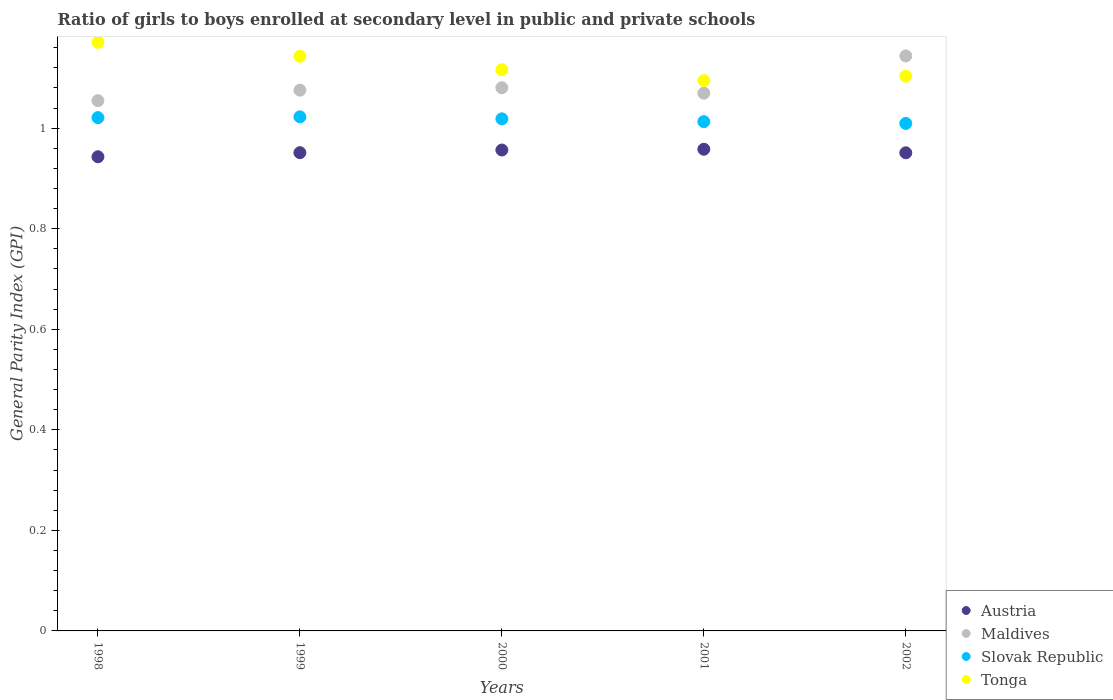How many different coloured dotlines are there?
Keep it short and to the point. 4. What is the general parity index in Slovak Republic in 1999?
Ensure brevity in your answer.  1.02. Across all years, what is the maximum general parity index in Austria?
Your answer should be compact. 0.96. Across all years, what is the minimum general parity index in Maldives?
Your response must be concise. 1.05. In which year was the general parity index in Austria maximum?
Provide a succinct answer. 2001. What is the total general parity index in Austria in the graph?
Ensure brevity in your answer.  4.76. What is the difference between the general parity index in Maldives in 1998 and that in 2000?
Provide a short and direct response. -0.03. What is the difference between the general parity index in Austria in 2002 and the general parity index in Maldives in 2000?
Keep it short and to the point. -0.13. What is the average general parity index in Slovak Republic per year?
Your answer should be very brief. 1.02. In the year 2001, what is the difference between the general parity index in Maldives and general parity index in Slovak Republic?
Provide a short and direct response. 0.06. In how many years, is the general parity index in Slovak Republic greater than 0.16?
Provide a short and direct response. 5. What is the ratio of the general parity index in Austria in 2001 to that in 2002?
Offer a very short reply. 1.01. Is the general parity index in Tonga in 1998 less than that in 2002?
Your answer should be compact. No. What is the difference between the highest and the second highest general parity index in Slovak Republic?
Your answer should be compact. 0. What is the difference between the highest and the lowest general parity index in Austria?
Make the answer very short. 0.01. Is it the case that in every year, the sum of the general parity index in Maldives and general parity index in Austria  is greater than the general parity index in Tonga?
Keep it short and to the point. Yes. Does the general parity index in Austria monotonically increase over the years?
Ensure brevity in your answer.  No. Is the general parity index in Tonga strictly greater than the general parity index in Austria over the years?
Ensure brevity in your answer.  Yes. How many years are there in the graph?
Make the answer very short. 5. Are the values on the major ticks of Y-axis written in scientific E-notation?
Your answer should be compact. No. Does the graph contain any zero values?
Offer a very short reply. No. Where does the legend appear in the graph?
Provide a succinct answer. Bottom right. What is the title of the graph?
Offer a very short reply. Ratio of girls to boys enrolled at secondary level in public and private schools. Does "Gabon" appear as one of the legend labels in the graph?
Your response must be concise. No. What is the label or title of the Y-axis?
Provide a short and direct response. General Parity Index (GPI). What is the General Parity Index (GPI) in Austria in 1998?
Your answer should be compact. 0.94. What is the General Parity Index (GPI) of Maldives in 1998?
Ensure brevity in your answer.  1.05. What is the General Parity Index (GPI) in Slovak Republic in 1998?
Your answer should be compact. 1.02. What is the General Parity Index (GPI) in Tonga in 1998?
Your answer should be very brief. 1.17. What is the General Parity Index (GPI) of Austria in 1999?
Give a very brief answer. 0.95. What is the General Parity Index (GPI) in Maldives in 1999?
Offer a very short reply. 1.08. What is the General Parity Index (GPI) in Slovak Republic in 1999?
Your answer should be very brief. 1.02. What is the General Parity Index (GPI) of Tonga in 1999?
Offer a very short reply. 1.14. What is the General Parity Index (GPI) of Austria in 2000?
Keep it short and to the point. 0.96. What is the General Parity Index (GPI) of Maldives in 2000?
Give a very brief answer. 1.08. What is the General Parity Index (GPI) of Slovak Republic in 2000?
Ensure brevity in your answer.  1.02. What is the General Parity Index (GPI) in Tonga in 2000?
Your answer should be very brief. 1.12. What is the General Parity Index (GPI) of Austria in 2001?
Offer a terse response. 0.96. What is the General Parity Index (GPI) of Maldives in 2001?
Provide a succinct answer. 1.07. What is the General Parity Index (GPI) of Slovak Republic in 2001?
Provide a succinct answer. 1.01. What is the General Parity Index (GPI) in Tonga in 2001?
Offer a terse response. 1.09. What is the General Parity Index (GPI) in Austria in 2002?
Offer a terse response. 0.95. What is the General Parity Index (GPI) of Maldives in 2002?
Give a very brief answer. 1.14. What is the General Parity Index (GPI) of Slovak Republic in 2002?
Provide a short and direct response. 1.01. What is the General Parity Index (GPI) in Tonga in 2002?
Provide a short and direct response. 1.1. Across all years, what is the maximum General Parity Index (GPI) in Austria?
Make the answer very short. 0.96. Across all years, what is the maximum General Parity Index (GPI) of Maldives?
Make the answer very short. 1.14. Across all years, what is the maximum General Parity Index (GPI) in Slovak Republic?
Provide a succinct answer. 1.02. Across all years, what is the maximum General Parity Index (GPI) of Tonga?
Your response must be concise. 1.17. Across all years, what is the minimum General Parity Index (GPI) in Austria?
Make the answer very short. 0.94. Across all years, what is the minimum General Parity Index (GPI) of Maldives?
Your answer should be very brief. 1.05. Across all years, what is the minimum General Parity Index (GPI) in Slovak Republic?
Give a very brief answer. 1.01. Across all years, what is the minimum General Parity Index (GPI) of Tonga?
Ensure brevity in your answer.  1.09. What is the total General Parity Index (GPI) of Austria in the graph?
Ensure brevity in your answer.  4.76. What is the total General Parity Index (GPI) of Maldives in the graph?
Provide a short and direct response. 5.42. What is the total General Parity Index (GPI) in Slovak Republic in the graph?
Offer a terse response. 5.08. What is the total General Parity Index (GPI) of Tonga in the graph?
Ensure brevity in your answer.  5.63. What is the difference between the General Parity Index (GPI) of Austria in 1998 and that in 1999?
Offer a very short reply. -0.01. What is the difference between the General Parity Index (GPI) in Maldives in 1998 and that in 1999?
Offer a very short reply. -0.02. What is the difference between the General Parity Index (GPI) of Slovak Republic in 1998 and that in 1999?
Your answer should be very brief. -0. What is the difference between the General Parity Index (GPI) of Tonga in 1998 and that in 1999?
Provide a short and direct response. 0.03. What is the difference between the General Parity Index (GPI) of Austria in 1998 and that in 2000?
Ensure brevity in your answer.  -0.01. What is the difference between the General Parity Index (GPI) of Maldives in 1998 and that in 2000?
Your answer should be compact. -0.03. What is the difference between the General Parity Index (GPI) of Slovak Republic in 1998 and that in 2000?
Your answer should be very brief. 0. What is the difference between the General Parity Index (GPI) of Tonga in 1998 and that in 2000?
Provide a succinct answer. 0.05. What is the difference between the General Parity Index (GPI) of Austria in 1998 and that in 2001?
Your answer should be very brief. -0.01. What is the difference between the General Parity Index (GPI) in Maldives in 1998 and that in 2001?
Provide a short and direct response. -0.01. What is the difference between the General Parity Index (GPI) of Slovak Republic in 1998 and that in 2001?
Your response must be concise. 0.01. What is the difference between the General Parity Index (GPI) of Tonga in 1998 and that in 2001?
Offer a very short reply. 0.08. What is the difference between the General Parity Index (GPI) in Austria in 1998 and that in 2002?
Ensure brevity in your answer.  -0.01. What is the difference between the General Parity Index (GPI) in Maldives in 1998 and that in 2002?
Keep it short and to the point. -0.09. What is the difference between the General Parity Index (GPI) in Slovak Republic in 1998 and that in 2002?
Your answer should be compact. 0.01. What is the difference between the General Parity Index (GPI) in Tonga in 1998 and that in 2002?
Your response must be concise. 0.07. What is the difference between the General Parity Index (GPI) of Austria in 1999 and that in 2000?
Keep it short and to the point. -0.01. What is the difference between the General Parity Index (GPI) of Maldives in 1999 and that in 2000?
Your answer should be very brief. -0. What is the difference between the General Parity Index (GPI) of Slovak Republic in 1999 and that in 2000?
Provide a succinct answer. 0. What is the difference between the General Parity Index (GPI) in Tonga in 1999 and that in 2000?
Provide a succinct answer. 0.03. What is the difference between the General Parity Index (GPI) in Austria in 1999 and that in 2001?
Give a very brief answer. -0.01. What is the difference between the General Parity Index (GPI) in Maldives in 1999 and that in 2001?
Offer a very short reply. 0.01. What is the difference between the General Parity Index (GPI) in Slovak Republic in 1999 and that in 2001?
Provide a short and direct response. 0.01. What is the difference between the General Parity Index (GPI) in Tonga in 1999 and that in 2001?
Keep it short and to the point. 0.05. What is the difference between the General Parity Index (GPI) of Maldives in 1999 and that in 2002?
Ensure brevity in your answer.  -0.07. What is the difference between the General Parity Index (GPI) in Slovak Republic in 1999 and that in 2002?
Provide a short and direct response. 0.01. What is the difference between the General Parity Index (GPI) of Tonga in 1999 and that in 2002?
Your response must be concise. 0.04. What is the difference between the General Parity Index (GPI) of Austria in 2000 and that in 2001?
Your answer should be very brief. -0. What is the difference between the General Parity Index (GPI) in Maldives in 2000 and that in 2001?
Offer a very short reply. 0.01. What is the difference between the General Parity Index (GPI) of Slovak Republic in 2000 and that in 2001?
Your answer should be compact. 0.01. What is the difference between the General Parity Index (GPI) of Tonga in 2000 and that in 2001?
Your answer should be compact. 0.02. What is the difference between the General Parity Index (GPI) in Austria in 2000 and that in 2002?
Offer a terse response. 0.01. What is the difference between the General Parity Index (GPI) of Maldives in 2000 and that in 2002?
Offer a terse response. -0.06. What is the difference between the General Parity Index (GPI) of Slovak Republic in 2000 and that in 2002?
Provide a short and direct response. 0.01. What is the difference between the General Parity Index (GPI) of Tonga in 2000 and that in 2002?
Provide a succinct answer. 0.01. What is the difference between the General Parity Index (GPI) of Austria in 2001 and that in 2002?
Your answer should be compact. 0.01. What is the difference between the General Parity Index (GPI) of Maldives in 2001 and that in 2002?
Give a very brief answer. -0.07. What is the difference between the General Parity Index (GPI) in Slovak Republic in 2001 and that in 2002?
Ensure brevity in your answer.  0. What is the difference between the General Parity Index (GPI) of Tonga in 2001 and that in 2002?
Offer a very short reply. -0.01. What is the difference between the General Parity Index (GPI) in Austria in 1998 and the General Parity Index (GPI) in Maldives in 1999?
Your response must be concise. -0.13. What is the difference between the General Parity Index (GPI) in Austria in 1998 and the General Parity Index (GPI) in Slovak Republic in 1999?
Offer a terse response. -0.08. What is the difference between the General Parity Index (GPI) in Maldives in 1998 and the General Parity Index (GPI) in Slovak Republic in 1999?
Ensure brevity in your answer.  0.03. What is the difference between the General Parity Index (GPI) of Maldives in 1998 and the General Parity Index (GPI) of Tonga in 1999?
Your response must be concise. -0.09. What is the difference between the General Parity Index (GPI) in Slovak Republic in 1998 and the General Parity Index (GPI) in Tonga in 1999?
Provide a succinct answer. -0.12. What is the difference between the General Parity Index (GPI) in Austria in 1998 and the General Parity Index (GPI) in Maldives in 2000?
Give a very brief answer. -0.14. What is the difference between the General Parity Index (GPI) in Austria in 1998 and the General Parity Index (GPI) in Slovak Republic in 2000?
Your response must be concise. -0.08. What is the difference between the General Parity Index (GPI) in Austria in 1998 and the General Parity Index (GPI) in Tonga in 2000?
Provide a short and direct response. -0.17. What is the difference between the General Parity Index (GPI) of Maldives in 1998 and the General Parity Index (GPI) of Slovak Republic in 2000?
Give a very brief answer. 0.04. What is the difference between the General Parity Index (GPI) of Maldives in 1998 and the General Parity Index (GPI) of Tonga in 2000?
Keep it short and to the point. -0.06. What is the difference between the General Parity Index (GPI) of Slovak Republic in 1998 and the General Parity Index (GPI) of Tonga in 2000?
Your answer should be very brief. -0.1. What is the difference between the General Parity Index (GPI) of Austria in 1998 and the General Parity Index (GPI) of Maldives in 2001?
Offer a terse response. -0.13. What is the difference between the General Parity Index (GPI) of Austria in 1998 and the General Parity Index (GPI) of Slovak Republic in 2001?
Your answer should be very brief. -0.07. What is the difference between the General Parity Index (GPI) of Austria in 1998 and the General Parity Index (GPI) of Tonga in 2001?
Your answer should be compact. -0.15. What is the difference between the General Parity Index (GPI) in Maldives in 1998 and the General Parity Index (GPI) in Slovak Republic in 2001?
Offer a terse response. 0.04. What is the difference between the General Parity Index (GPI) in Maldives in 1998 and the General Parity Index (GPI) in Tonga in 2001?
Offer a terse response. -0.04. What is the difference between the General Parity Index (GPI) in Slovak Republic in 1998 and the General Parity Index (GPI) in Tonga in 2001?
Keep it short and to the point. -0.07. What is the difference between the General Parity Index (GPI) of Austria in 1998 and the General Parity Index (GPI) of Maldives in 2002?
Your response must be concise. -0.2. What is the difference between the General Parity Index (GPI) in Austria in 1998 and the General Parity Index (GPI) in Slovak Republic in 2002?
Your response must be concise. -0.07. What is the difference between the General Parity Index (GPI) of Austria in 1998 and the General Parity Index (GPI) of Tonga in 2002?
Make the answer very short. -0.16. What is the difference between the General Parity Index (GPI) of Maldives in 1998 and the General Parity Index (GPI) of Slovak Republic in 2002?
Keep it short and to the point. 0.05. What is the difference between the General Parity Index (GPI) in Maldives in 1998 and the General Parity Index (GPI) in Tonga in 2002?
Ensure brevity in your answer.  -0.05. What is the difference between the General Parity Index (GPI) in Slovak Republic in 1998 and the General Parity Index (GPI) in Tonga in 2002?
Your answer should be compact. -0.08. What is the difference between the General Parity Index (GPI) in Austria in 1999 and the General Parity Index (GPI) in Maldives in 2000?
Your answer should be compact. -0.13. What is the difference between the General Parity Index (GPI) of Austria in 1999 and the General Parity Index (GPI) of Slovak Republic in 2000?
Make the answer very short. -0.07. What is the difference between the General Parity Index (GPI) in Austria in 1999 and the General Parity Index (GPI) in Tonga in 2000?
Your answer should be very brief. -0.16. What is the difference between the General Parity Index (GPI) in Maldives in 1999 and the General Parity Index (GPI) in Slovak Republic in 2000?
Your response must be concise. 0.06. What is the difference between the General Parity Index (GPI) in Maldives in 1999 and the General Parity Index (GPI) in Tonga in 2000?
Provide a short and direct response. -0.04. What is the difference between the General Parity Index (GPI) in Slovak Republic in 1999 and the General Parity Index (GPI) in Tonga in 2000?
Your answer should be compact. -0.09. What is the difference between the General Parity Index (GPI) in Austria in 1999 and the General Parity Index (GPI) in Maldives in 2001?
Your response must be concise. -0.12. What is the difference between the General Parity Index (GPI) of Austria in 1999 and the General Parity Index (GPI) of Slovak Republic in 2001?
Give a very brief answer. -0.06. What is the difference between the General Parity Index (GPI) in Austria in 1999 and the General Parity Index (GPI) in Tonga in 2001?
Offer a terse response. -0.14. What is the difference between the General Parity Index (GPI) of Maldives in 1999 and the General Parity Index (GPI) of Slovak Republic in 2001?
Your answer should be compact. 0.06. What is the difference between the General Parity Index (GPI) of Maldives in 1999 and the General Parity Index (GPI) of Tonga in 2001?
Provide a short and direct response. -0.02. What is the difference between the General Parity Index (GPI) of Slovak Republic in 1999 and the General Parity Index (GPI) of Tonga in 2001?
Your answer should be very brief. -0.07. What is the difference between the General Parity Index (GPI) of Austria in 1999 and the General Parity Index (GPI) of Maldives in 2002?
Provide a short and direct response. -0.19. What is the difference between the General Parity Index (GPI) of Austria in 1999 and the General Parity Index (GPI) of Slovak Republic in 2002?
Offer a terse response. -0.06. What is the difference between the General Parity Index (GPI) in Austria in 1999 and the General Parity Index (GPI) in Tonga in 2002?
Provide a short and direct response. -0.15. What is the difference between the General Parity Index (GPI) of Maldives in 1999 and the General Parity Index (GPI) of Slovak Republic in 2002?
Keep it short and to the point. 0.07. What is the difference between the General Parity Index (GPI) in Maldives in 1999 and the General Parity Index (GPI) in Tonga in 2002?
Make the answer very short. -0.03. What is the difference between the General Parity Index (GPI) of Slovak Republic in 1999 and the General Parity Index (GPI) of Tonga in 2002?
Offer a very short reply. -0.08. What is the difference between the General Parity Index (GPI) in Austria in 2000 and the General Parity Index (GPI) in Maldives in 2001?
Offer a very short reply. -0.11. What is the difference between the General Parity Index (GPI) of Austria in 2000 and the General Parity Index (GPI) of Slovak Republic in 2001?
Give a very brief answer. -0.06. What is the difference between the General Parity Index (GPI) of Austria in 2000 and the General Parity Index (GPI) of Tonga in 2001?
Offer a terse response. -0.14. What is the difference between the General Parity Index (GPI) in Maldives in 2000 and the General Parity Index (GPI) in Slovak Republic in 2001?
Your answer should be compact. 0.07. What is the difference between the General Parity Index (GPI) of Maldives in 2000 and the General Parity Index (GPI) of Tonga in 2001?
Your answer should be compact. -0.01. What is the difference between the General Parity Index (GPI) in Slovak Republic in 2000 and the General Parity Index (GPI) in Tonga in 2001?
Ensure brevity in your answer.  -0.08. What is the difference between the General Parity Index (GPI) in Austria in 2000 and the General Parity Index (GPI) in Maldives in 2002?
Offer a very short reply. -0.19. What is the difference between the General Parity Index (GPI) of Austria in 2000 and the General Parity Index (GPI) of Slovak Republic in 2002?
Offer a very short reply. -0.05. What is the difference between the General Parity Index (GPI) of Austria in 2000 and the General Parity Index (GPI) of Tonga in 2002?
Your response must be concise. -0.15. What is the difference between the General Parity Index (GPI) of Maldives in 2000 and the General Parity Index (GPI) of Slovak Republic in 2002?
Offer a terse response. 0.07. What is the difference between the General Parity Index (GPI) of Maldives in 2000 and the General Parity Index (GPI) of Tonga in 2002?
Ensure brevity in your answer.  -0.02. What is the difference between the General Parity Index (GPI) in Slovak Republic in 2000 and the General Parity Index (GPI) in Tonga in 2002?
Your response must be concise. -0.08. What is the difference between the General Parity Index (GPI) of Austria in 2001 and the General Parity Index (GPI) of Maldives in 2002?
Provide a succinct answer. -0.19. What is the difference between the General Parity Index (GPI) in Austria in 2001 and the General Parity Index (GPI) in Slovak Republic in 2002?
Provide a succinct answer. -0.05. What is the difference between the General Parity Index (GPI) in Austria in 2001 and the General Parity Index (GPI) in Tonga in 2002?
Make the answer very short. -0.15. What is the difference between the General Parity Index (GPI) of Maldives in 2001 and the General Parity Index (GPI) of Slovak Republic in 2002?
Your answer should be very brief. 0.06. What is the difference between the General Parity Index (GPI) of Maldives in 2001 and the General Parity Index (GPI) of Tonga in 2002?
Offer a very short reply. -0.03. What is the difference between the General Parity Index (GPI) in Slovak Republic in 2001 and the General Parity Index (GPI) in Tonga in 2002?
Your answer should be very brief. -0.09. What is the average General Parity Index (GPI) of Maldives per year?
Your response must be concise. 1.08. What is the average General Parity Index (GPI) in Slovak Republic per year?
Provide a short and direct response. 1.02. What is the average General Parity Index (GPI) of Tonga per year?
Provide a succinct answer. 1.13. In the year 1998, what is the difference between the General Parity Index (GPI) in Austria and General Parity Index (GPI) in Maldives?
Your response must be concise. -0.11. In the year 1998, what is the difference between the General Parity Index (GPI) in Austria and General Parity Index (GPI) in Slovak Republic?
Your answer should be compact. -0.08. In the year 1998, what is the difference between the General Parity Index (GPI) of Austria and General Parity Index (GPI) of Tonga?
Your answer should be very brief. -0.23. In the year 1998, what is the difference between the General Parity Index (GPI) of Maldives and General Parity Index (GPI) of Slovak Republic?
Your answer should be very brief. 0.03. In the year 1998, what is the difference between the General Parity Index (GPI) of Maldives and General Parity Index (GPI) of Tonga?
Keep it short and to the point. -0.12. In the year 1998, what is the difference between the General Parity Index (GPI) in Slovak Republic and General Parity Index (GPI) in Tonga?
Provide a short and direct response. -0.15. In the year 1999, what is the difference between the General Parity Index (GPI) of Austria and General Parity Index (GPI) of Maldives?
Offer a terse response. -0.12. In the year 1999, what is the difference between the General Parity Index (GPI) of Austria and General Parity Index (GPI) of Slovak Republic?
Ensure brevity in your answer.  -0.07. In the year 1999, what is the difference between the General Parity Index (GPI) in Austria and General Parity Index (GPI) in Tonga?
Ensure brevity in your answer.  -0.19. In the year 1999, what is the difference between the General Parity Index (GPI) in Maldives and General Parity Index (GPI) in Slovak Republic?
Provide a short and direct response. 0.05. In the year 1999, what is the difference between the General Parity Index (GPI) in Maldives and General Parity Index (GPI) in Tonga?
Your answer should be very brief. -0.07. In the year 1999, what is the difference between the General Parity Index (GPI) of Slovak Republic and General Parity Index (GPI) of Tonga?
Offer a very short reply. -0.12. In the year 2000, what is the difference between the General Parity Index (GPI) in Austria and General Parity Index (GPI) in Maldives?
Your answer should be compact. -0.12. In the year 2000, what is the difference between the General Parity Index (GPI) in Austria and General Parity Index (GPI) in Slovak Republic?
Your answer should be very brief. -0.06. In the year 2000, what is the difference between the General Parity Index (GPI) of Austria and General Parity Index (GPI) of Tonga?
Ensure brevity in your answer.  -0.16. In the year 2000, what is the difference between the General Parity Index (GPI) of Maldives and General Parity Index (GPI) of Slovak Republic?
Keep it short and to the point. 0.06. In the year 2000, what is the difference between the General Parity Index (GPI) in Maldives and General Parity Index (GPI) in Tonga?
Provide a short and direct response. -0.04. In the year 2000, what is the difference between the General Parity Index (GPI) in Slovak Republic and General Parity Index (GPI) in Tonga?
Keep it short and to the point. -0.1. In the year 2001, what is the difference between the General Parity Index (GPI) of Austria and General Parity Index (GPI) of Maldives?
Give a very brief answer. -0.11. In the year 2001, what is the difference between the General Parity Index (GPI) in Austria and General Parity Index (GPI) in Slovak Republic?
Give a very brief answer. -0.05. In the year 2001, what is the difference between the General Parity Index (GPI) of Austria and General Parity Index (GPI) of Tonga?
Make the answer very short. -0.14. In the year 2001, what is the difference between the General Parity Index (GPI) in Maldives and General Parity Index (GPI) in Slovak Republic?
Provide a succinct answer. 0.06. In the year 2001, what is the difference between the General Parity Index (GPI) in Maldives and General Parity Index (GPI) in Tonga?
Give a very brief answer. -0.03. In the year 2001, what is the difference between the General Parity Index (GPI) in Slovak Republic and General Parity Index (GPI) in Tonga?
Offer a terse response. -0.08. In the year 2002, what is the difference between the General Parity Index (GPI) of Austria and General Parity Index (GPI) of Maldives?
Provide a short and direct response. -0.19. In the year 2002, what is the difference between the General Parity Index (GPI) of Austria and General Parity Index (GPI) of Slovak Republic?
Your answer should be compact. -0.06. In the year 2002, what is the difference between the General Parity Index (GPI) in Austria and General Parity Index (GPI) in Tonga?
Ensure brevity in your answer.  -0.15. In the year 2002, what is the difference between the General Parity Index (GPI) in Maldives and General Parity Index (GPI) in Slovak Republic?
Offer a terse response. 0.13. In the year 2002, what is the difference between the General Parity Index (GPI) in Maldives and General Parity Index (GPI) in Tonga?
Your answer should be compact. 0.04. In the year 2002, what is the difference between the General Parity Index (GPI) in Slovak Republic and General Parity Index (GPI) in Tonga?
Give a very brief answer. -0.09. What is the ratio of the General Parity Index (GPI) in Maldives in 1998 to that in 1999?
Offer a very short reply. 0.98. What is the ratio of the General Parity Index (GPI) of Tonga in 1998 to that in 1999?
Keep it short and to the point. 1.02. What is the ratio of the General Parity Index (GPI) of Austria in 1998 to that in 2000?
Give a very brief answer. 0.99. What is the ratio of the General Parity Index (GPI) of Maldives in 1998 to that in 2000?
Make the answer very short. 0.98. What is the ratio of the General Parity Index (GPI) of Tonga in 1998 to that in 2000?
Offer a very short reply. 1.05. What is the ratio of the General Parity Index (GPI) in Austria in 1998 to that in 2001?
Give a very brief answer. 0.98. What is the ratio of the General Parity Index (GPI) in Maldives in 1998 to that in 2001?
Give a very brief answer. 0.99. What is the ratio of the General Parity Index (GPI) of Slovak Republic in 1998 to that in 2001?
Keep it short and to the point. 1.01. What is the ratio of the General Parity Index (GPI) in Tonga in 1998 to that in 2001?
Provide a succinct answer. 1.07. What is the ratio of the General Parity Index (GPI) of Maldives in 1998 to that in 2002?
Your response must be concise. 0.92. What is the ratio of the General Parity Index (GPI) of Slovak Republic in 1998 to that in 2002?
Your answer should be compact. 1.01. What is the ratio of the General Parity Index (GPI) of Tonga in 1998 to that in 2002?
Offer a terse response. 1.06. What is the ratio of the General Parity Index (GPI) in Maldives in 1999 to that in 2000?
Offer a very short reply. 1. What is the ratio of the General Parity Index (GPI) in Tonga in 1999 to that in 2000?
Offer a very short reply. 1.02. What is the ratio of the General Parity Index (GPI) of Maldives in 1999 to that in 2001?
Make the answer very short. 1.01. What is the ratio of the General Parity Index (GPI) in Slovak Republic in 1999 to that in 2001?
Offer a terse response. 1.01. What is the ratio of the General Parity Index (GPI) of Tonga in 1999 to that in 2001?
Ensure brevity in your answer.  1.04. What is the ratio of the General Parity Index (GPI) of Austria in 1999 to that in 2002?
Your response must be concise. 1. What is the ratio of the General Parity Index (GPI) in Maldives in 1999 to that in 2002?
Your response must be concise. 0.94. What is the ratio of the General Parity Index (GPI) in Tonga in 1999 to that in 2002?
Provide a short and direct response. 1.04. What is the ratio of the General Parity Index (GPI) of Tonga in 2000 to that in 2001?
Give a very brief answer. 1.02. What is the ratio of the General Parity Index (GPI) of Maldives in 2000 to that in 2002?
Offer a terse response. 0.94. What is the ratio of the General Parity Index (GPI) of Slovak Republic in 2000 to that in 2002?
Your response must be concise. 1.01. What is the ratio of the General Parity Index (GPI) of Tonga in 2000 to that in 2002?
Your answer should be compact. 1.01. What is the ratio of the General Parity Index (GPI) in Austria in 2001 to that in 2002?
Offer a very short reply. 1.01. What is the ratio of the General Parity Index (GPI) of Maldives in 2001 to that in 2002?
Your response must be concise. 0.94. What is the ratio of the General Parity Index (GPI) of Slovak Republic in 2001 to that in 2002?
Provide a succinct answer. 1. What is the ratio of the General Parity Index (GPI) in Tonga in 2001 to that in 2002?
Ensure brevity in your answer.  0.99. What is the difference between the highest and the second highest General Parity Index (GPI) in Austria?
Your answer should be compact. 0. What is the difference between the highest and the second highest General Parity Index (GPI) in Maldives?
Make the answer very short. 0.06. What is the difference between the highest and the second highest General Parity Index (GPI) of Slovak Republic?
Offer a terse response. 0. What is the difference between the highest and the second highest General Parity Index (GPI) of Tonga?
Keep it short and to the point. 0.03. What is the difference between the highest and the lowest General Parity Index (GPI) in Austria?
Your answer should be very brief. 0.01. What is the difference between the highest and the lowest General Parity Index (GPI) in Maldives?
Your answer should be very brief. 0.09. What is the difference between the highest and the lowest General Parity Index (GPI) of Slovak Republic?
Give a very brief answer. 0.01. What is the difference between the highest and the lowest General Parity Index (GPI) of Tonga?
Make the answer very short. 0.08. 